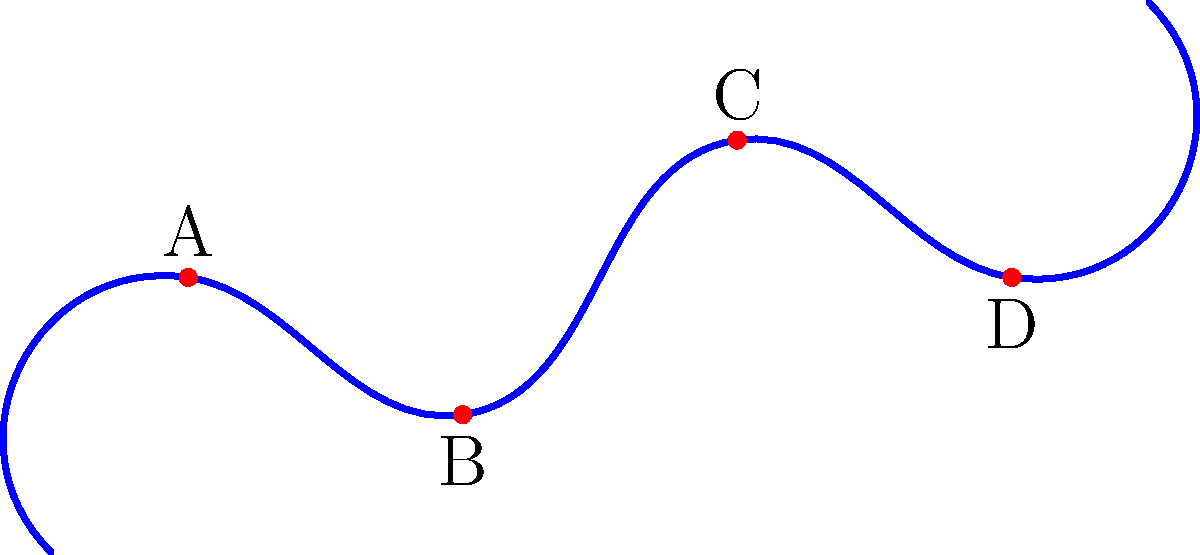In the topological map of a rock face shown above, which sequence of holds (A, B, C, D) would provide the most efficient climbing route, considering the principle of maintaining three points of contact? To determine the most efficient climbing route while maintaining three points of contact, we need to analyze the positions of the holds and their relative distances:

1. Start at the bottom left of the rock face.
2. Hold A is the first and lowest hold, so it's the logical starting point.
3. From A, the climber needs to move to either B or C.
4. B is closer to A and at a lower height, making it easier to reach while maintaining three points of contact (both feet and one hand on A).
5. After B, the next logical move is to C, as it's the next closest hold and allows for an upward progression.
6. Finally, from C, the climber can reach D to complete the route.

The principle of maintaining three points of contact is crucial for stability and safety in rock climbing. This sequence (A → B → C → D) allows the climber to always have at least two feet and one hand, or two hands and one foot, in contact with the rock face at any given time.

This route also follows a natural upward progression, minimizing unnecessary vertical movements and conserving energy.
Answer: A → B → C → D 